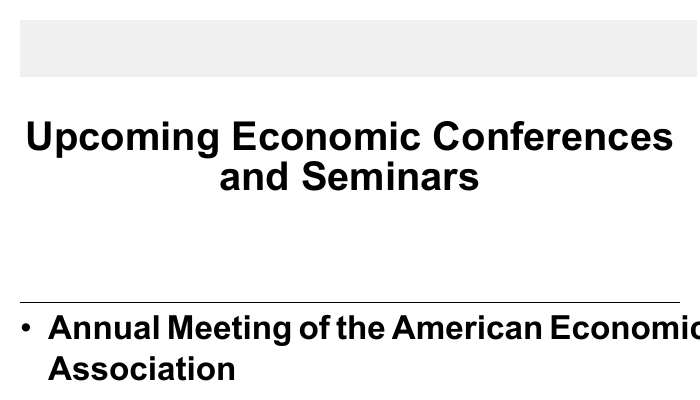What is the first conference listed? The first conference mentioned in the document is the Annual Meeting of the American Economic Association.
Answer: Annual Meeting of the American Economic Association When is the European Economic Association Conference scheduled? The date provided for the European Economic Association Conference is August 26-30, 2024.
Answer: August 26-30, 2024 Where will the World Economic Forum Annual Meeting take place? According to the document, the World Economic Forum Annual Meeting will be held in Davos, Switzerland.
Answer: Davos, Switzerland How many days will The Econometric Society World Congress last? The document states that The Econometric Society World Congress will last for five days, from July 14-18, 2024.
Answer: Five days What is the location of the Symposium on Economics and Finance? The document specifies that the Symposium on Economics and Finance will occur in London, UK.
Answer: London, UK What type of discussions is the document promoting? The footnote indicates that the card is intended for rational economic discussions only.
Answer: Rational economic discussions only What is the title of the conference occurring in January 2024? The conference happening in January 2024 is the World Economic Forum Annual Meeting.
Answer: World Economic Forum Annual Meeting Which conference has the longest duration listed? The document suggests that The Econometric Society World Congress has the longest duration, spanning five days.
Answer: The Econometric Society World Congress How many total conferences are listed in the document? Counting the events provided, there are five conferences listed.
Answer: Five conferences 